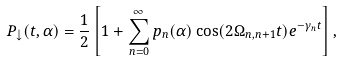Convert formula to latex. <formula><loc_0><loc_0><loc_500><loc_500>P _ { \downarrow } ( t , \alpha ) = \frac { 1 } { 2 } \left [ 1 + \sum _ { n = 0 } ^ { \infty } p _ { n } ( \alpha ) \cos ( 2 \Omega _ { n , n + 1 } t ) e ^ { - \gamma _ { n } t } \right ] ,</formula> 